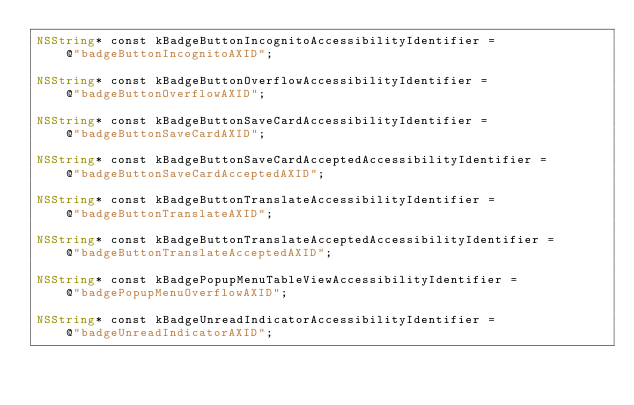Convert code to text. <code><loc_0><loc_0><loc_500><loc_500><_ObjectiveC_>NSString* const kBadgeButtonIncognitoAccessibilityIdentifier =
    @"badgeButtonIncognitoAXID";

NSString* const kBadgeButtonOverflowAccessibilityIdentifier =
    @"badgeButtonOverflowAXID";

NSString* const kBadgeButtonSaveCardAccessibilityIdentifier =
    @"badgeButtonSaveCardAXID";

NSString* const kBadgeButtonSaveCardAcceptedAccessibilityIdentifier =
    @"badgeButtonSaveCardAcceptedAXID";

NSString* const kBadgeButtonTranslateAccessibilityIdentifier =
    @"badgeButtonTranslateAXID";

NSString* const kBadgeButtonTranslateAcceptedAccessibilityIdentifier =
    @"badgeButtonTranslateAcceptedAXID";

NSString* const kBadgePopupMenuTableViewAccessibilityIdentifier =
    @"badgePopupMenuOverflowAXID";

NSString* const kBadgeUnreadIndicatorAccessibilityIdentifier =
    @"badgeUnreadIndicatorAXID";
</code> 